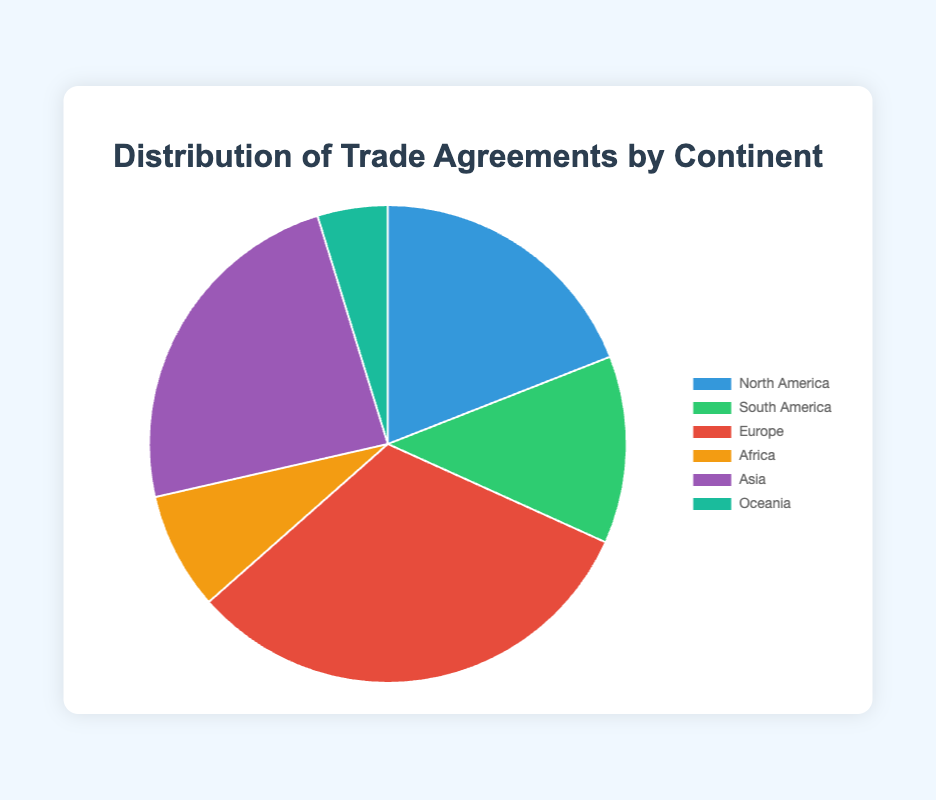What is the continent with the highest number of trade agreements? By observing the pie chart, we can see that the sector representing Europe has the largest portion. This indicates that Europe has the highest number of trade agreements.
Answer: Europe How many more trade agreements does Asia have compared to Oceania? From the chart, Asia has 15 trade agreements and Oceania has 3. The difference is calculated by subtracting Oceania's value from Asia's value: 15 - 3 = 12.
Answer: 12 What percentage of the total trade agreements does North America represent? To find the percentage, first sum the total number of trade agreements (12 + 8 + 20 + 5 + 15 + 3 = 63). Then, divide the number of North American trade agreements by the total and multiply by 100: (12 / 63) * 100 ≈ 19.05%.
Answer: 19.05% Which continents have fewer trade agreements than Asia? By comparing the number of trade agreements, Asia has 15 agreements. North America (12), South America (8), Africa (5), and Oceania (3) have fewer trade agreements than Asia.
Answer: North America, South America, Africa, Oceania Which segment in the pie chart is represented by the color blue? The blue segment corresponds to North America, as indicated by the chart legend which maps colors to continents.
Answer: North America What is the combined number of trade agreements for South America and Africa? Add the number of trade agreements for South America (8) and Africa (5): 8 + 5 = 13.
Answer: 13 How does the number of trade agreements in Europe compare with those in South America and Africa combined? Europe has 20 trade agreements. South America and Africa together have 13. Since 20 is greater than 13, Europe has more trade agreements.
Answer: Europe has more If we exclude Europe's trade agreements, what fraction of total trade agreements is made up by Asia? Excluding Europe, the total number of trade agreements is (12 + 8 + 5 + 15 + 3 = 43). The fraction for Asia is calculated as 15 / 43.
Answer: 15/43 